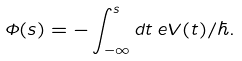<formula> <loc_0><loc_0><loc_500><loc_500>\Phi ( s ) = - \int _ { - \infty } ^ { s } d t \, e V ( t ) / \hbar { . }</formula> 